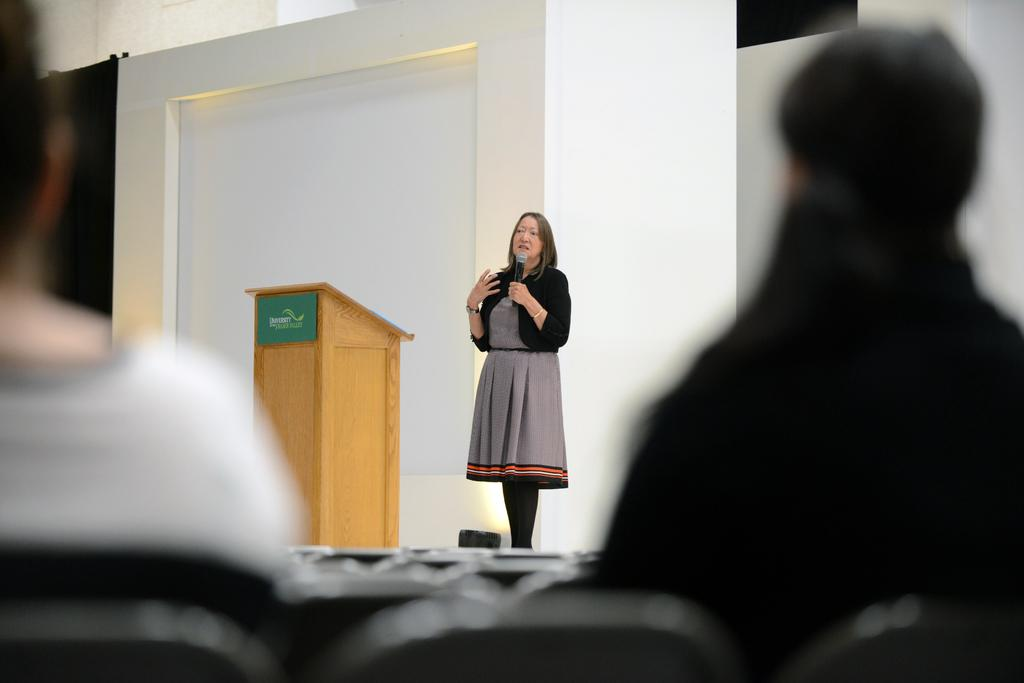Who is the main subject in the image? There is a woman in the image. What is the woman doing in the image? The woman is standing on a dais and holding a microphone in one of her hands. What can be seen in the background of the image? There is a podium and walls visible in the background of the image. Where is the sink located in the image? There is no sink present in the image. What type of body is visible in the image? The image only features a woman, so there is no other body visible. 